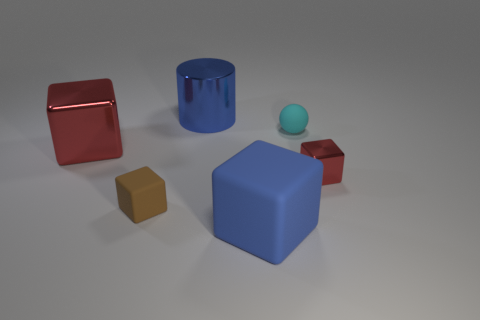What is the shape of the thing that is behind the large red block and to the right of the big matte object?
Make the answer very short. Sphere. What is the size of the red block right of the tiny object that is left of the tiny cyan thing?
Offer a terse response. Small. What number of other objects are there of the same color as the shiny cylinder?
Offer a terse response. 1. What material is the big cylinder?
Offer a very short reply. Metal. Is there a big rubber ball?
Your answer should be very brief. No. Are there the same number of large blue metallic cylinders in front of the cyan rubber ball and large metallic objects?
Your answer should be very brief. No. Is there any other thing that has the same material as the blue cube?
Provide a succinct answer. Yes. What number of large things are either cyan matte things or blue cubes?
Your answer should be compact. 1. There is a large rubber object that is the same color as the cylinder; what shape is it?
Keep it short and to the point. Cube. Is the material of the large blue thing that is in front of the brown rubber cube the same as the tiny cyan thing?
Keep it short and to the point. Yes. 